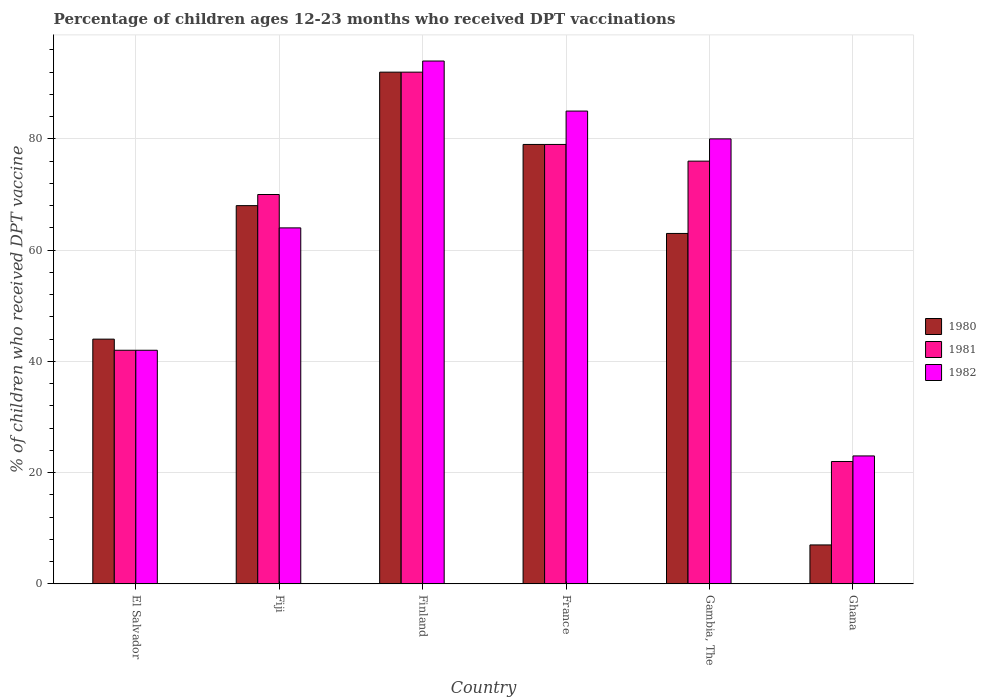How many different coloured bars are there?
Offer a very short reply. 3. How many groups of bars are there?
Your answer should be compact. 6. Are the number of bars on each tick of the X-axis equal?
Keep it short and to the point. Yes. How many bars are there on the 3rd tick from the right?
Your answer should be very brief. 3. What is the label of the 3rd group of bars from the left?
Offer a very short reply. Finland. What is the percentage of children who received DPT vaccination in 1981 in Ghana?
Give a very brief answer. 22. Across all countries, what is the maximum percentage of children who received DPT vaccination in 1982?
Your answer should be very brief. 94. Across all countries, what is the minimum percentage of children who received DPT vaccination in 1982?
Keep it short and to the point. 23. In which country was the percentage of children who received DPT vaccination in 1980 maximum?
Your answer should be compact. Finland. What is the total percentage of children who received DPT vaccination in 1980 in the graph?
Give a very brief answer. 353. What is the difference between the percentage of children who received DPT vaccination in 1980 in Gambia, The and that in Ghana?
Provide a succinct answer. 56. What is the difference between the percentage of children who received DPT vaccination in 1980 in Ghana and the percentage of children who received DPT vaccination in 1982 in Finland?
Provide a short and direct response. -87. What is the average percentage of children who received DPT vaccination in 1981 per country?
Ensure brevity in your answer.  63.5. What is the ratio of the percentage of children who received DPT vaccination in 1982 in El Salvador to that in Fiji?
Offer a very short reply. 0.66. What is the difference between the highest and the second highest percentage of children who received DPT vaccination in 1981?
Your response must be concise. 16. What is the difference between the highest and the lowest percentage of children who received DPT vaccination in 1980?
Ensure brevity in your answer.  85. Is the sum of the percentage of children who received DPT vaccination in 1980 in El Salvador and Ghana greater than the maximum percentage of children who received DPT vaccination in 1982 across all countries?
Your answer should be very brief. No. What does the 2nd bar from the left in Fiji represents?
Ensure brevity in your answer.  1981. Are all the bars in the graph horizontal?
Keep it short and to the point. No. Where does the legend appear in the graph?
Give a very brief answer. Center right. How many legend labels are there?
Provide a short and direct response. 3. What is the title of the graph?
Your answer should be compact. Percentage of children ages 12-23 months who received DPT vaccinations. What is the label or title of the X-axis?
Your answer should be very brief. Country. What is the label or title of the Y-axis?
Provide a short and direct response. % of children who received DPT vaccine. What is the % of children who received DPT vaccine of 1980 in Fiji?
Provide a succinct answer. 68. What is the % of children who received DPT vaccine in 1981 in Fiji?
Offer a terse response. 70. What is the % of children who received DPT vaccine of 1982 in Fiji?
Provide a succinct answer. 64. What is the % of children who received DPT vaccine of 1980 in Finland?
Your response must be concise. 92. What is the % of children who received DPT vaccine in 1981 in Finland?
Keep it short and to the point. 92. What is the % of children who received DPT vaccine in 1982 in Finland?
Your answer should be compact. 94. What is the % of children who received DPT vaccine in 1980 in France?
Provide a succinct answer. 79. What is the % of children who received DPT vaccine in 1981 in France?
Provide a short and direct response. 79. What is the % of children who received DPT vaccine of 1981 in Gambia, The?
Your answer should be very brief. 76. What is the % of children who received DPT vaccine of 1982 in Gambia, The?
Offer a very short reply. 80. What is the % of children who received DPT vaccine of 1981 in Ghana?
Your answer should be compact. 22. Across all countries, what is the maximum % of children who received DPT vaccine in 1980?
Your answer should be compact. 92. Across all countries, what is the maximum % of children who received DPT vaccine of 1981?
Ensure brevity in your answer.  92. Across all countries, what is the maximum % of children who received DPT vaccine of 1982?
Offer a very short reply. 94. Across all countries, what is the minimum % of children who received DPT vaccine in 1982?
Give a very brief answer. 23. What is the total % of children who received DPT vaccine in 1980 in the graph?
Give a very brief answer. 353. What is the total % of children who received DPT vaccine of 1981 in the graph?
Ensure brevity in your answer.  381. What is the total % of children who received DPT vaccine of 1982 in the graph?
Offer a terse response. 388. What is the difference between the % of children who received DPT vaccine in 1980 in El Salvador and that in Fiji?
Ensure brevity in your answer.  -24. What is the difference between the % of children who received DPT vaccine in 1981 in El Salvador and that in Fiji?
Your response must be concise. -28. What is the difference between the % of children who received DPT vaccine in 1980 in El Salvador and that in Finland?
Make the answer very short. -48. What is the difference between the % of children who received DPT vaccine of 1981 in El Salvador and that in Finland?
Give a very brief answer. -50. What is the difference between the % of children who received DPT vaccine of 1982 in El Salvador and that in Finland?
Your answer should be compact. -52. What is the difference between the % of children who received DPT vaccine in 1980 in El Salvador and that in France?
Provide a short and direct response. -35. What is the difference between the % of children who received DPT vaccine in 1981 in El Salvador and that in France?
Ensure brevity in your answer.  -37. What is the difference between the % of children who received DPT vaccine of 1982 in El Salvador and that in France?
Offer a terse response. -43. What is the difference between the % of children who received DPT vaccine in 1980 in El Salvador and that in Gambia, The?
Offer a terse response. -19. What is the difference between the % of children who received DPT vaccine of 1981 in El Salvador and that in Gambia, The?
Offer a very short reply. -34. What is the difference between the % of children who received DPT vaccine of 1982 in El Salvador and that in Gambia, The?
Provide a short and direct response. -38. What is the difference between the % of children who received DPT vaccine of 1980 in El Salvador and that in Ghana?
Give a very brief answer. 37. What is the difference between the % of children who received DPT vaccine of 1981 in El Salvador and that in Ghana?
Make the answer very short. 20. What is the difference between the % of children who received DPT vaccine in 1980 in Fiji and that in Finland?
Keep it short and to the point. -24. What is the difference between the % of children who received DPT vaccine of 1980 in Fiji and that in France?
Offer a terse response. -11. What is the difference between the % of children who received DPT vaccine in 1980 in Fiji and that in Gambia, The?
Your response must be concise. 5. What is the difference between the % of children who received DPT vaccine in 1982 in Fiji and that in Gambia, The?
Ensure brevity in your answer.  -16. What is the difference between the % of children who received DPT vaccine in 1980 in Fiji and that in Ghana?
Offer a terse response. 61. What is the difference between the % of children who received DPT vaccine of 1981 in Fiji and that in Ghana?
Your answer should be very brief. 48. What is the difference between the % of children who received DPT vaccine in 1982 in Fiji and that in Ghana?
Give a very brief answer. 41. What is the difference between the % of children who received DPT vaccine of 1980 in Finland and that in France?
Your answer should be compact. 13. What is the difference between the % of children who received DPT vaccine in 1981 in Finland and that in France?
Ensure brevity in your answer.  13. What is the difference between the % of children who received DPT vaccine in 1982 in Finland and that in France?
Provide a succinct answer. 9. What is the difference between the % of children who received DPT vaccine of 1980 in Finland and that in Gambia, The?
Your response must be concise. 29. What is the difference between the % of children who received DPT vaccine of 1980 in Finland and that in Ghana?
Give a very brief answer. 85. What is the difference between the % of children who received DPT vaccine of 1982 in Finland and that in Ghana?
Your answer should be very brief. 71. What is the difference between the % of children who received DPT vaccine in 1980 in France and that in Gambia, The?
Your answer should be very brief. 16. What is the difference between the % of children who received DPT vaccine in 1981 in France and that in Gambia, The?
Your answer should be compact. 3. What is the difference between the % of children who received DPT vaccine in 1982 in France and that in Gambia, The?
Make the answer very short. 5. What is the difference between the % of children who received DPT vaccine of 1981 in France and that in Ghana?
Keep it short and to the point. 57. What is the difference between the % of children who received DPT vaccine of 1982 in France and that in Ghana?
Ensure brevity in your answer.  62. What is the difference between the % of children who received DPT vaccine in 1982 in Gambia, The and that in Ghana?
Offer a terse response. 57. What is the difference between the % of children who received DPT vaccine of 1980 in El Salvador and the % of children who received DPT vaccine of 1981 in Fiji?
Your response must be concise. -26. What is the difference between the % of children who received DPT vaccine in 1981 in El Salvador and the % of children who received DPT vaccine in 1982 in Fiji?
Offer a terse response. -22. What is the difference between the % of children who received DPT vaccine of 1980 in El Salvador and the % of children who received DPT vaccine of 1981 in Finland?
Provide a short and direct response. -48. What is the difference between the % of children who received DPT vaccine in 1981 in El Salvador and the % of children who received DPT vaccine in 1982 in Finland?
Make the answer very short. -52. What is the difference between the % of children who received DPT vaccine in 1980 in El Salvador and the % of children who received DPT vaccine in 1981 in France?
Provide a short and direct response. -35. What is the difference between the % of children who received DPT vaccine in 1980 in El Salvador and the % of children who received DPT vaccine in 1982 in France?
Your response must be concise. -41. What is the difference between the % of children who received DPT vaccine in 1981 in El Salvador and the % of children who received DPT vaccine in 1982 in France?
Your answer should be compact. -43. What is the difference between the % of children who received DPT vaccine in 1980 in El Salvador and the % of children who received DPT vaccine in 1981 in Gambia, The?
Your answer should be very brief. -32. What is the difference between the % of children who received DPT vaccine of 1980 in El Salvador and the % of children who received DPT vaccine of 1982 in Gambia, The?
Make the answer very short. -36. What is the difference between the % of children who received DPT vaccine in 1981 in El Salvador and the % of children who received DPT vaccine in 1982 in Gambia, The?
Provide a succinct answer. -38. What is the difference between the % of children who received DPT vaccine of 1980 in El Salvador and the % of children who received DPT vaccine of 1982 in Ghana?
Ensure brevity in your answer.  21. What is the difference between the % of children who received DPT vaccine of 1981 in El Salvador and the % of children who received DPT vaccine of 1982 in Ghana?
Make the answer very short. 19. What is the difference between the % of children who received DPT vaccine in 1980 in Fiji and the % of children who received DPT vaccine in 1981 in Finland?
Make the answer very short. -24. What is the difference between the % of children who received DPT vaccine in 1981 in Fiji and the % of children who received DPT vaccine in 1982 in Finland?
Provide a succinct answer. -24. What is the difference between the % of children who received DPT vaccine in 1980 in Fiji and the % of children who received DPT vaccine in 1981 in France?
Your answer should be very brief. -11. What is the difference between the % of children who received DPT vaccine in 1980 in Fiji and the % of children who received DPT vaccine in 1982 in France?
Make the answer very short. -17. What is the difference between the % of children who received DPT vaccine in 1980 in Fiji and the % of children who received DPT vaccine in 1981 in Ghana?
Offer a terse response. 46. What is the difference between the % of children who received DPT vaccine of 1980 in Fiji and the % of children who received DPT vaccine of 1982 in Ghana?
Provide a short and direct response. 45. What is the difference between the % of children who received DPT vaccine of 1981 in Fiji and the % of children who received DPT vaccine of 1982 in Ghana?
Offer a very short reply. 47. What is the difference between the % of children who received DPT vaccine in 1980 in Finland and the % of children who received DPT vaccine in 1982 in France?
Provide a short and direct response. 7. What is the difference between the % of children who received DPT vaccine of 1981 in Finland and the % of children who received DPT vaccine of 1982 in France?
Keep it short and to the point. 7. What is the difference between the % of children who received DPT vaccine in 1980 in Finland and the % of children who received DPT vaccine in 1981 in Gambia, The?
Provide a short and direct response. 16. What is the difference between the % of children who received DPT vaccine in 1981 in Finland and the % of children who received DPT vaccine in 1982 in Gambia, The?
Make the answer very short. 12. What is the difference between the % of children who received DPT vaccine of 1980 in Finland and the % of children who received DPT vaccine of 1981 in Ghana?
Provide a short and direct response. 70. What is the difference between the % of children who received DPT vaccine of 1981 in Finland and the % of children who received DPT vaccine of 1982 in Ghana?
Your answer should be compact. 69. What is the difference between the % of children who received DPT vaccine in 1980 in France and the % of children who received DPT vaccine in 1982 in Gambia, The?
Give a very brief answer. -1. What is the difference between the % of children who received DPT vaccine in 1980 in France and the % of children who received DPT vaccine in 1981 in Ghana?
Offer a very short reply. 57. What is the difference between the % of children who received DPT vaccine of 1980 in France and the % of children who received DPT vaccine of 1982 in Ghana?
Provide a short and direct response. 56. What is the difference between the % of children who received DPT vaccine of 1980 in Gambia, The and the % of children who received DPT vaccine of 1981 in Ghana?
Your answer should be very brief. 41. What is the difference between the % of children who received DPT vaccine of 1980 in Gambia, The and the % of children who received DPT vaccine of 1982 in Ghana?
Offer a terse response. 40. What is the difference between the % of children who received DPT vaccine of 1981 in Gambia, The and the % of children who received DPT vaccine of 1982 in Ghana?
Offer a terse response. 53. What is the average % of children who received DPT vaccine in 1980 per country?
Your answer should be compact. 58.83. What is the average % of children who received DPT vaccine in 1981 per country?
Ensure brevity in your answer.  63.5. What is the average % of children who received DPT vaccine of 1982 per country?
Provide a short and direct response. 64.67. What is the difference between the % of children who received DPT vaccine of 1980 and % of children who received DPT vaccine of 1982 in El Salvador?
Offer a terse response. 2. What is the difference between the % of children who received DPT vaccine in 1981 and % of children who received DPT vaccine in 1982 in El Salvador?
Provide a short and direct response. 0. What is the difference between the % of children who received DPT vaccine in 1980 and % of children who received DPT vaccine in 1981 in Fiji?
Provide a short and direct response. -2. What is the difference between the % of children who received DPT vaccine in 1980 and % of children who received DPT vaccine in 1982 in Fiji?
Give a very brief answer. 4. What is the difference between the % of children who received DPT vaccine of 1980 and % of children who received DPT vaccine of 1981 in Finland?
Offer a very short reply. 0. What is the difference between the % of children who received DPT vaccine in 1980 and % of children who received DPT vaccine in 1981 in France?
Keep it short and to the point. 0. What is the difference between the % of children who received DPT vaccine of 1980 and % of children who received DPT vaccine of 1982 in Gambia, The?
Provide a short and direct response. -17. What is the difference between the % of children who received DPT vaccine of 1981 and % of children who received DPT vaccine of 1982 in Gambia, The?
Offer a terse response. -4. What is the difference between the % of children who received DPT vaccine of 1980 and % of children who received DPT vaccine of 1981 in Ghana?
Your answer should be very brief. -15. What is the difference between the % of children who received DPT vaccine in 1980 and % of children who received DPT vaccine in 1982 in Ghana?
Ensure brevity in your answer.  -16. What is the difference between the % of children who received DPT vaccine of 1981 and % of children who received DPT vaccine of 1982 in Ghana?
Your answer should be compact. -1. What is the ratio of the % of children who received DPT vaccine of 1980 in El Salvador to that in Fiji?
Give a very brief answer. 0.65. What is the ratio of the % of children who received DPT vaccine in 1982 in El Salvador to that in Fiji?
Make the answer very short. 0.66. What is the ratio of the % of children who received DPT vaccine in 1980 in El Salvador to that in Finland?
Your answer should be very brief. 0.48. What is the ratio of the % of children who received DPT vaccine in 1981 in El Salvador to that in Finland?
Make the answer very short. 0.46. What is the ratio of the % of children who received DPT vaccine in 1982 in El Salvador to that in Finland?
Provide a short and direct response. 0.45. What is the ratio of the % of children who received DPT vaccine of 1980 in El Salvador to that in France?
Offer a very short reply. 0.56. What is the ratio of the % of children who received DPT vaccine of 1981 in El Salvador to that in France?
Your answer should be compact. 0.53. What is the ratio of the % of children who received DPT vaccine of 1982 in El Salvador to that in France?
Provide a short and direct response. 0.49. What is the ratio of the % of children who received DPT vaccine of 1980 in El Salvador to that in Gambia, The?
Give a very brief answer. 0.7. What is the ratio of the % of children who received DPT vaccine of 1981 in El Salvador to that in Gambia, The?
Provide a short and direct response. 0.55. What is the ratio of the % of children who received DPT vaccine of 1982 in El Salvador to that in Gambia, The?
Your response must be concise. 0.53. What is the ratio of the % of children who received DPT vaccine of 1980 in El Salvador to that in Ghana?
Your answer should be very brief. 6.29. What is the ratio of the % of children who received DPT vaccine of 1981 in El Salvador to that in Ghana?
Provide a succinct answer. 1.91. What is the ratio of the % of children who received DPT vaccine in 1982 in El Salvador to that in Ghana?
Ensure brevity in your answer.  1.83. What is the ratio of the % of children who received DPT vaccine in 1980 in Fiji to that in Finland?
Your response must be concise. 0.74. What is the ratio of the % of children who received DPT vaccine in 1981 in Fiji to that in Finland?
Keep it short and to the point. 0.76. What is the ratio of the % of children who received DPT vaccine in 1982 in Fiji to that in Finland?
Provide a succinct answer. 0.68. What is the ratio of the % of children who received DPT vaccine in 1980 in Fiji to that in France?
Offer a terse response. 0.86. What is the ratio of the % of children who received DPT vaccine in 1981 in Fiji to that in France?
Make the answer very short. 0.89. What is the ratio of the % of children who received DPT vaccine of 1982 in Fiji to that in France?
Provide a succinct answer. 0.75. What is the ratio of the % of children who received DPT vaccine of 1980 in Fiji to that in Gambia, The?
Offer a terse response. 1.08. What is the ratio of the % of children who received DPT vaccine in 1981 in Fiji to that in Gambia, The?
Ensure brevity in your answer.  0.92. What is the ratio of the % of children who received DPT vaccine in 1980 in Fiji to that in Ghana?
Offer a very short reply. 9.71. What is the ratio of the % of children who received DPT vaccine of 1981 in Fiji to that in Ghana?
Your answer should be very brief. 3.18. What is the ratio of the % of children who received DPT vaccine in 1982 in Fiji to that in Ghana?
Keep it short and to the point. 2.78. What is the ratio of the % of children who received DPT vaccine of 1980 in Finland to that in France?
Ensure brevity in your answer.  1.16. What is the ratio of the % of children who received DPT vaccine of 1981 in Finland to that in France?
Your answer should be compact. 1.16. What is the ratio of the % of children who received DPT vaccine of 1982 in Finland to that in France?
Provide a short and direct response. 1.11. What is the ratio of the % of children who received DPT vaccine of 1980 in Finland to that in Gambia, The?
Your answer should be very brief. 1.46. What is the ratio of the % of children who received DPT vaccine in 1981 in Finland to that in Gambia, The?
Ensure brevity in your answer.  1.21. What is the ratio of the % of children who received DPT vaccine of 1982 in Finland to that in Gambia, The?
Provide a succinct answer. 1.18. What is the ratio of the % of children who received DPT vaccine of 1980 in Finland to that in Ghana?
Provide a succinct answer. 13.14. What is the ratio of the % of children who received DPT vaccine of 1981 in Finland to that in Ghana?
Provide a succinct answer. 4.18. What is the ratio of the % of children who received DPT vaccine in 1982 in Finland to that in Ghana?
Keep it short and to the point. 4.09. What is the ratio of the % of children who received DPT vaccine of 1980 in France to that in Gambia, The?
Ensure brevity in your answer.  1.25. What is the ratio of the % of children who received DPT vaccine in 1981 in France to that in Gambia, The?
Keep it short and to the point. 1.04. What is the ratio of the % of children who received DPT vaccine in 1982 in France to that in Gambia, The?
Ensure brevity in your answer.  1.06. What is the ratio of the % of children who received DPT vaccine of 1980 in France to that in Ghana?
Offer a very short reply. 11.29. What is the ratio of the % of children who received DPT vaccine in 1981 in France to that in Ghana?
Provide a succinct answer. 3.59. What is the ratio of the % of children who received DPT vaccine in 1982 in France to that in Ghana?
Make the answer very short. 3.7. What is the ratio of the % of children who received DPT vaccine in 1981 in Gambia, The to that in Ghana?
Ensure brevity in your answer.  3.45. What is the ratio of the % of children who received DPT vaccine of 1982 in Gambia, The to that in Ghana?
Offer a terse response. 3.48. What is the difference between the highest and the second highest % of children who received DPT vaccine of 1980?
Your response must be concise. 13. What is the difference between the highest and the second highest % of children who received DPT vaccine of 1981?
Provide a succinct answer. 13. What is the difference between the highest and the second highest % of children who received DPT vaccine in 1982?
Make the answer very short. 9. What is the difference between the highest and the lowest % of children who received DPT vaccine of 1980?
Make the answer very short. 85. 